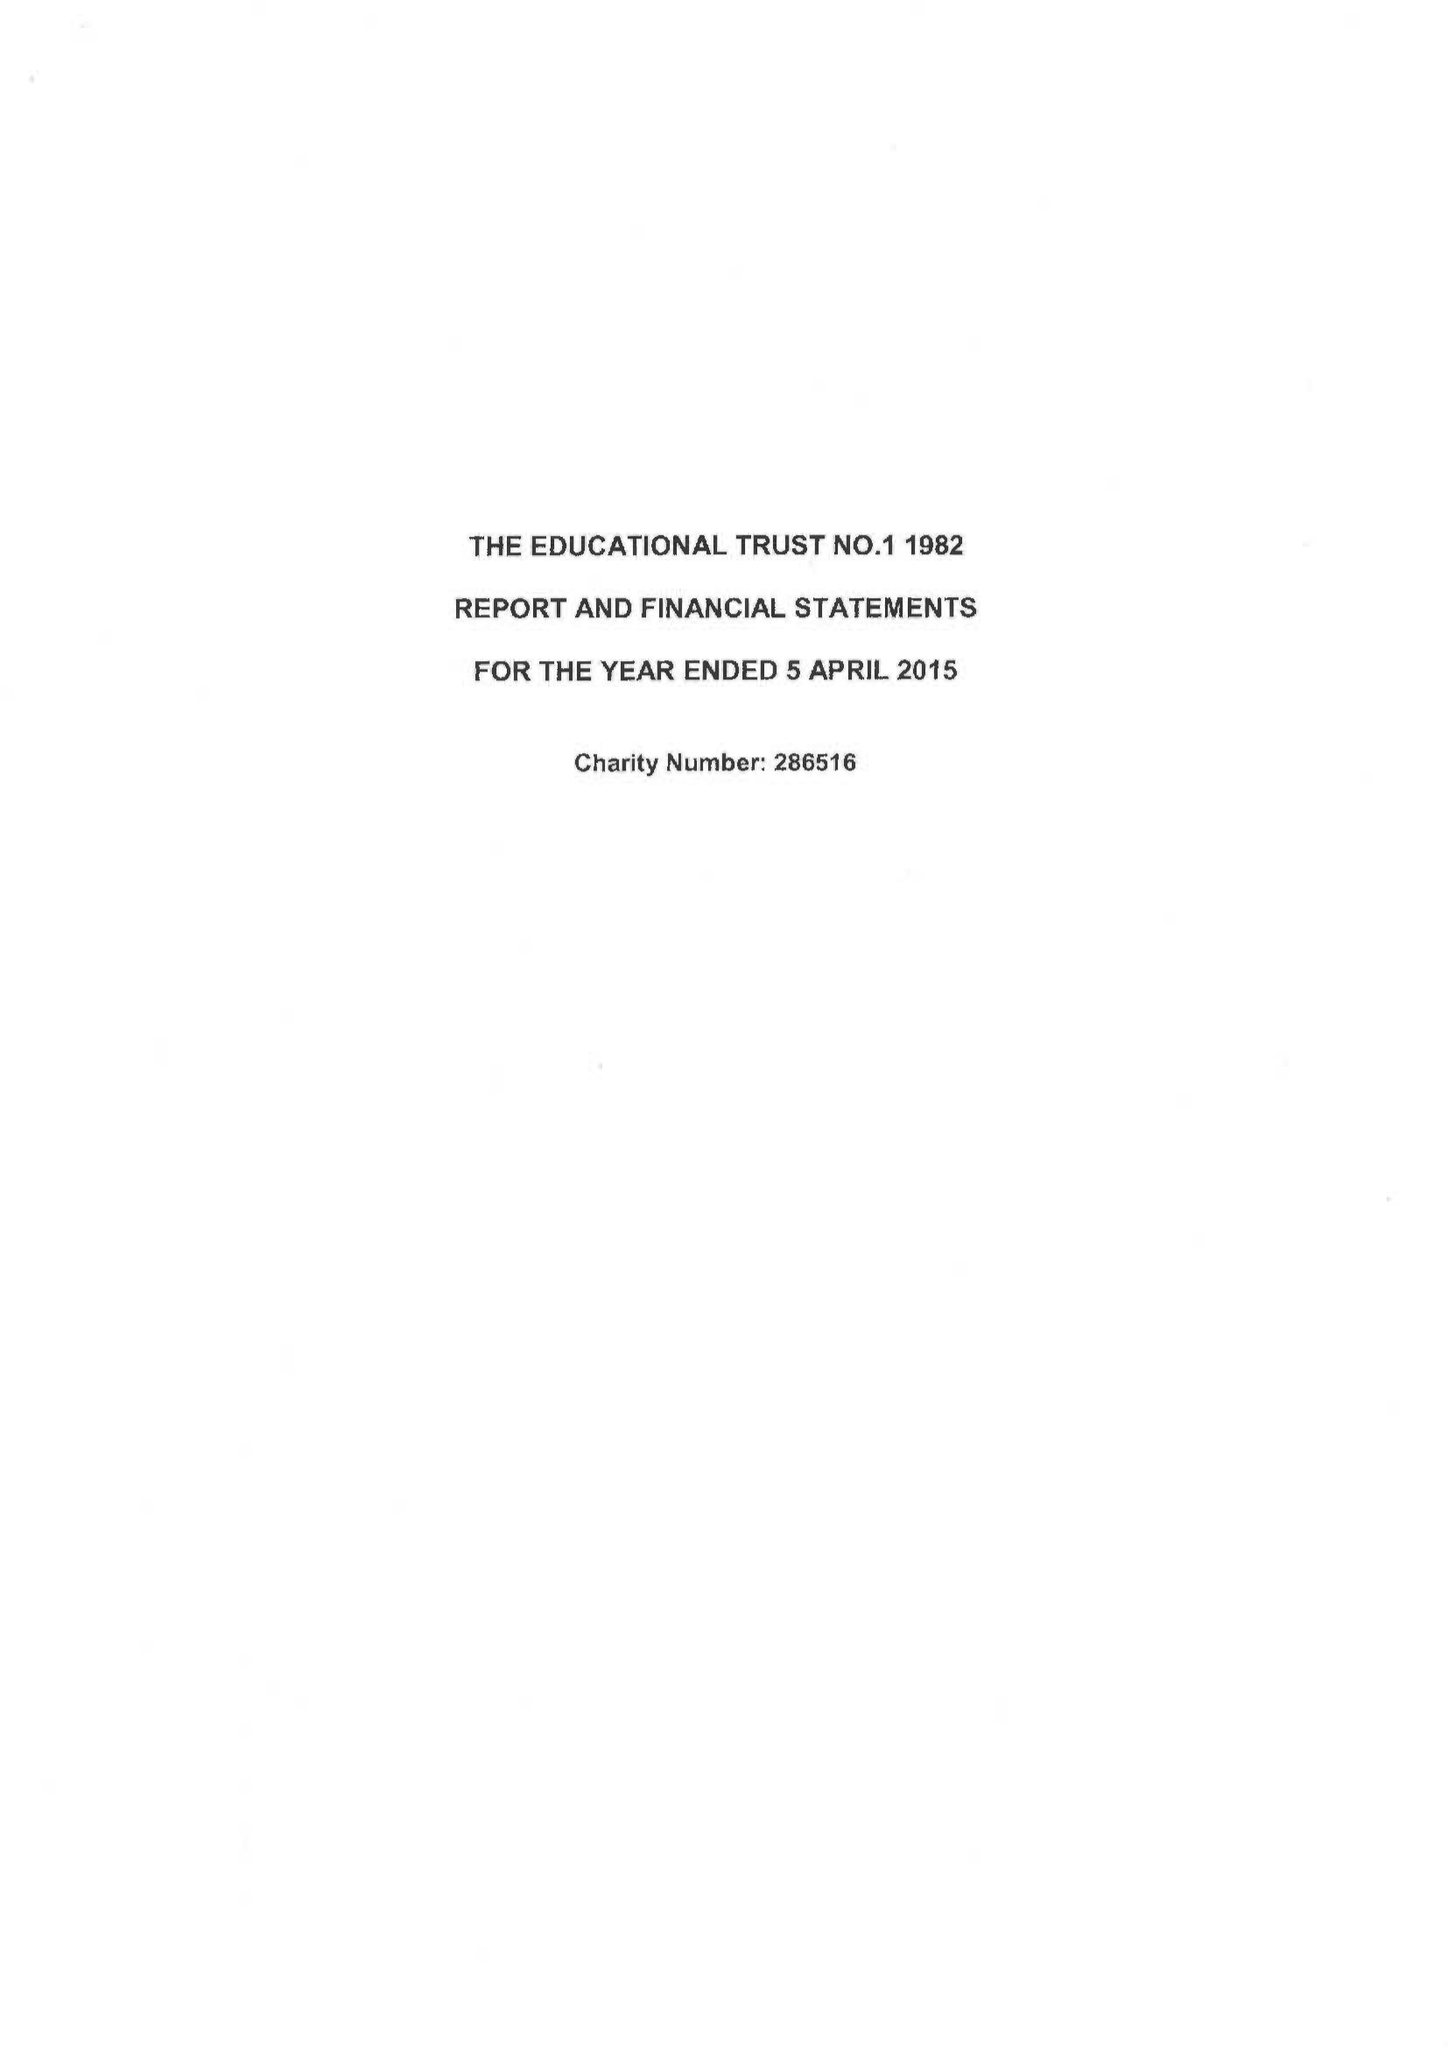What is the value for the charity_number?
Answer the question using a single word or phrase. 286516 